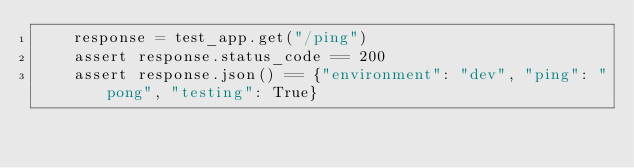<code> <loc_0><loc_0><loc_500><loc_500><_Python_>    response = test_app.get("/ping")
    assert response.status_code == 200
    assert response.json() == {"environment": "dev", "ping": "pong", "testing": True}
</code> 